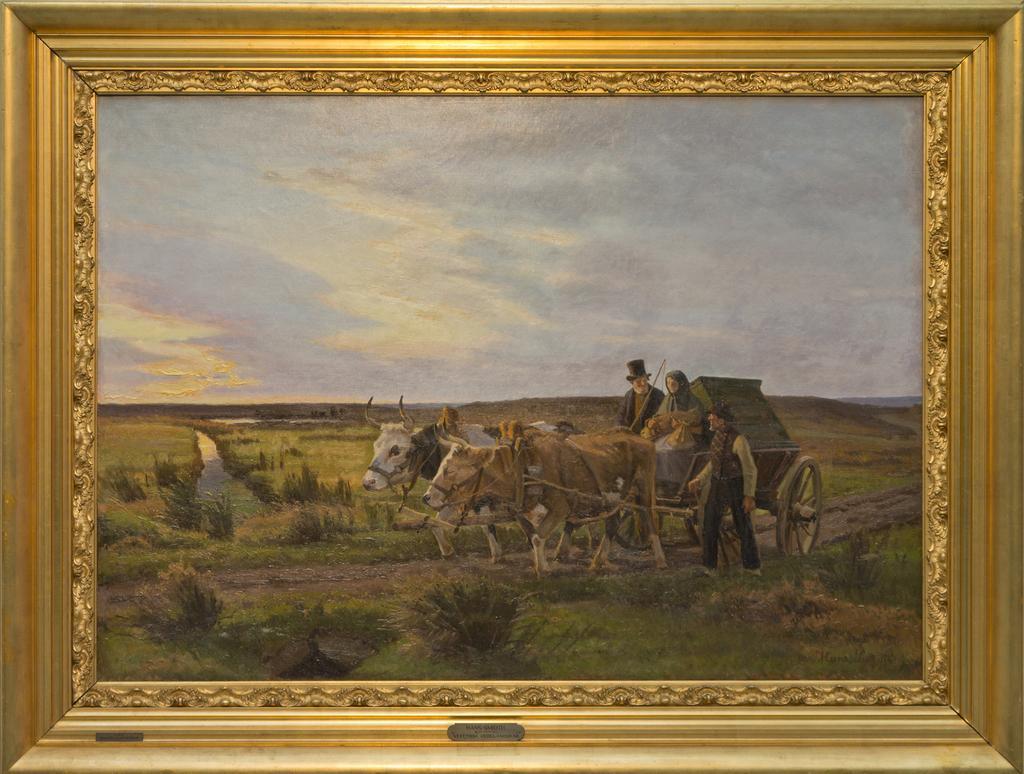Describe this image in one or two sentences. In this picture we can see a wall frame. 